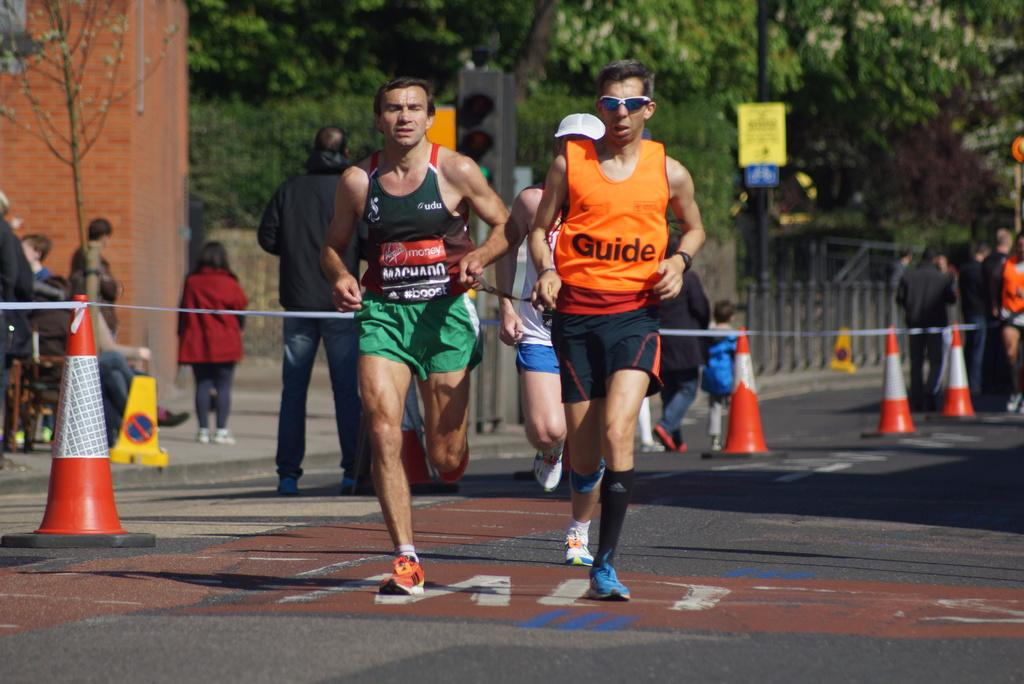Provide a one-sentence caption for the provided image. The advertisement on the left runner is from virgin mobile. 